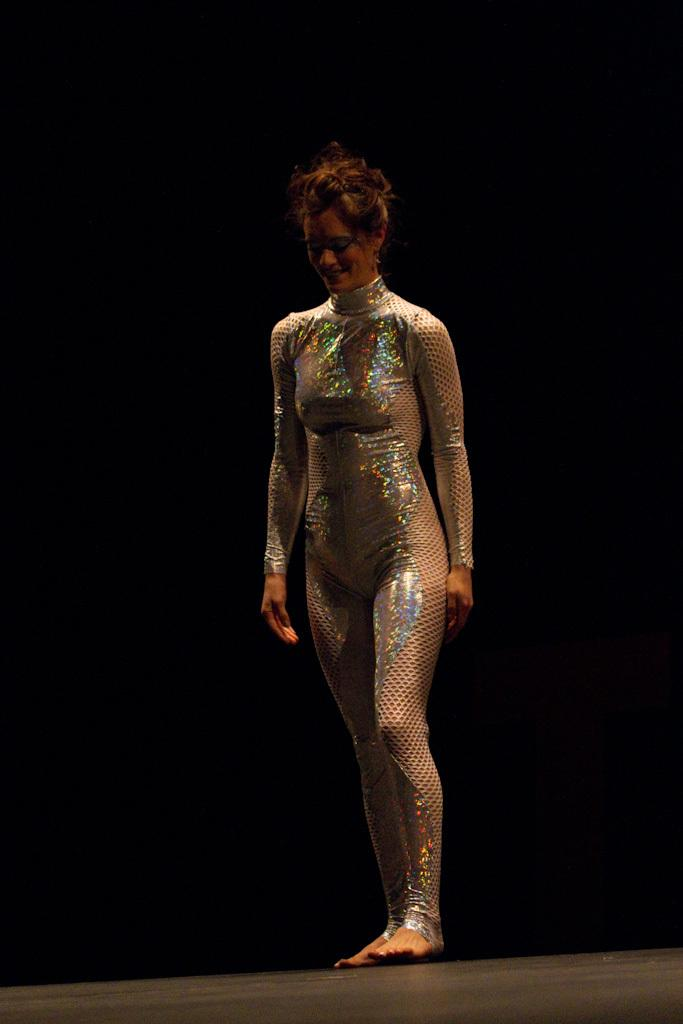Who is the main subject in the image? There is a woman in the image. What is the woman wearing? The woman is wearing a costume. What is the woman standing on? The woman is standing on a surface. What is the color of the background in the image? The background of the image is black in color. Is the woman sleeping in the image? No, the woman is not sleeping in the image; she is standing. 